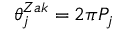Convert formula to latex. <formula><loc_0><loc_0><loc_500><loc_500>\theta _ { j } ^ { Z a k } = 2 \pi P _ { j }</formula> 